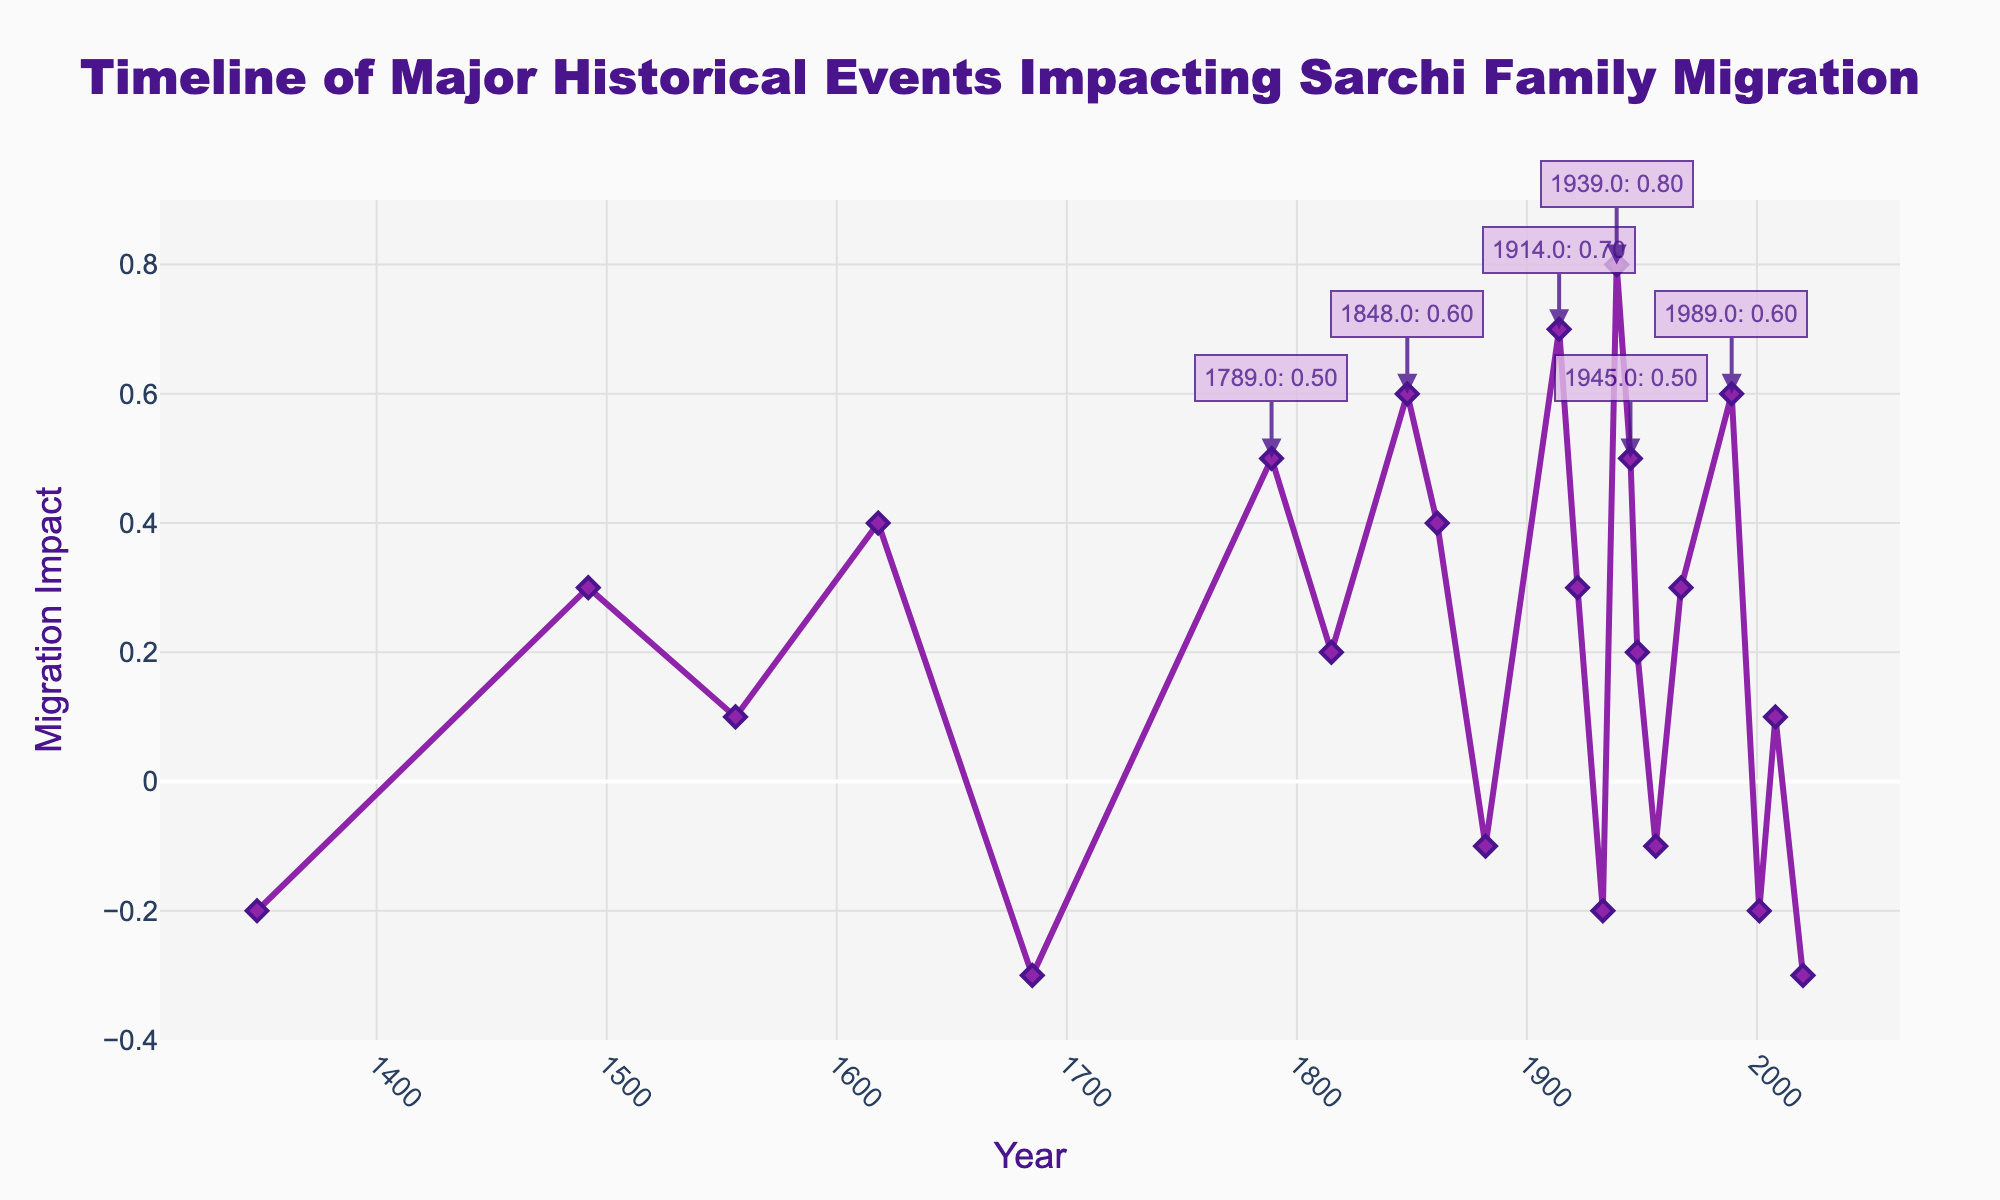What year had the highest positive migration impact on the Sarchi family? The highest point on the graph with the greatest positive value is at the year 1939, where the migration impact is 0.8.
Answer: 1939 What is the average migration impact of the events in 1939, 1945, and 1989? First, note the values: 1939 is 0.8, 1945 is 0.5, and 1989 is 0.6. Adding these gives 0.8 + 0.5 + 0.6 = 1.9. Dividing by 3, the number of events, gives the average: 1.9/3 = 0.633.
Answer: 0.633 Which years had a migration impact that is exactly 0.3? Refer to the graph to see that the years 1492, 1922, and 1967 each have a migration impact of 0.3.
Answer: 1492, 1922, 1967 Between which years did the Sarchi family experience the most significant negative change in migration impact? Look for the largest drop in the line graph. The most significant negative change occurs between 1685 (-0.3) and 1789 (0.5). The change is from -0.3 to 0.5 which is 0.5 - (-0.3) = 0.8.
Answer: 1685 and 1789 What is the median value of the migration impacts for the given years? To find the median, first list the migration impacts in ascending order: -0.3, -0.2, -0.2, -0.1, -0.1, 0.1, 0.1, 0.2, 0.2, 0.3, 0.3, 0.3, 0.4, 0.4, 0.5, 0.5, 0.6, 0.6, 0.7, 0.8. Since there are 21 data points, the median is the 11th value, which is 0.3.
Answer: 0.3 Which historical event caused the Sarchi family the greatest decrease in migration impact? The lowest point on the line graph represents the greatest negative value, which is in the year 1685 with a migration impact of -0.3.
Answer: 1685 How did the migration impact change from 1914 to 1922? In 1914, the migration impact is 0.7. By 1922, it is 0.3. The change is calculated as 0.3 - 0.7 = -0.4.
Answer: -0.4 What is the sum of the migration impacts from 1848 to 1882? The impacts for the years are as follows: 1848 (0.6), 1861 (0.4), 1882 (-0.1). Summing these values yields 0.6 + 0.4 - 0.1 = 0.9.
Answer: 0.9 Compare the migration impacts of 1348 and 1492. The migration impact in 1348 is -0.2, and in 1492 it is 0.3. 0.3 is greater than -0.2.
Answer: 1492 is greater than 1348 What is the range of the migration impacts shown on the timeline? The range is the difference between the maximum and minimum impacts. The highest impact is 0.8 (1939) and the lowest impact is -0.3 (1685, 2020). Calculating 0.8 - (-0.3) gives 1.1.
Answer: 1.1 